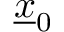Convert formula to latex. <formula><loc_0><loc_0><loc_500><loc_500>\underline { x } _ { 0 }</formula> 